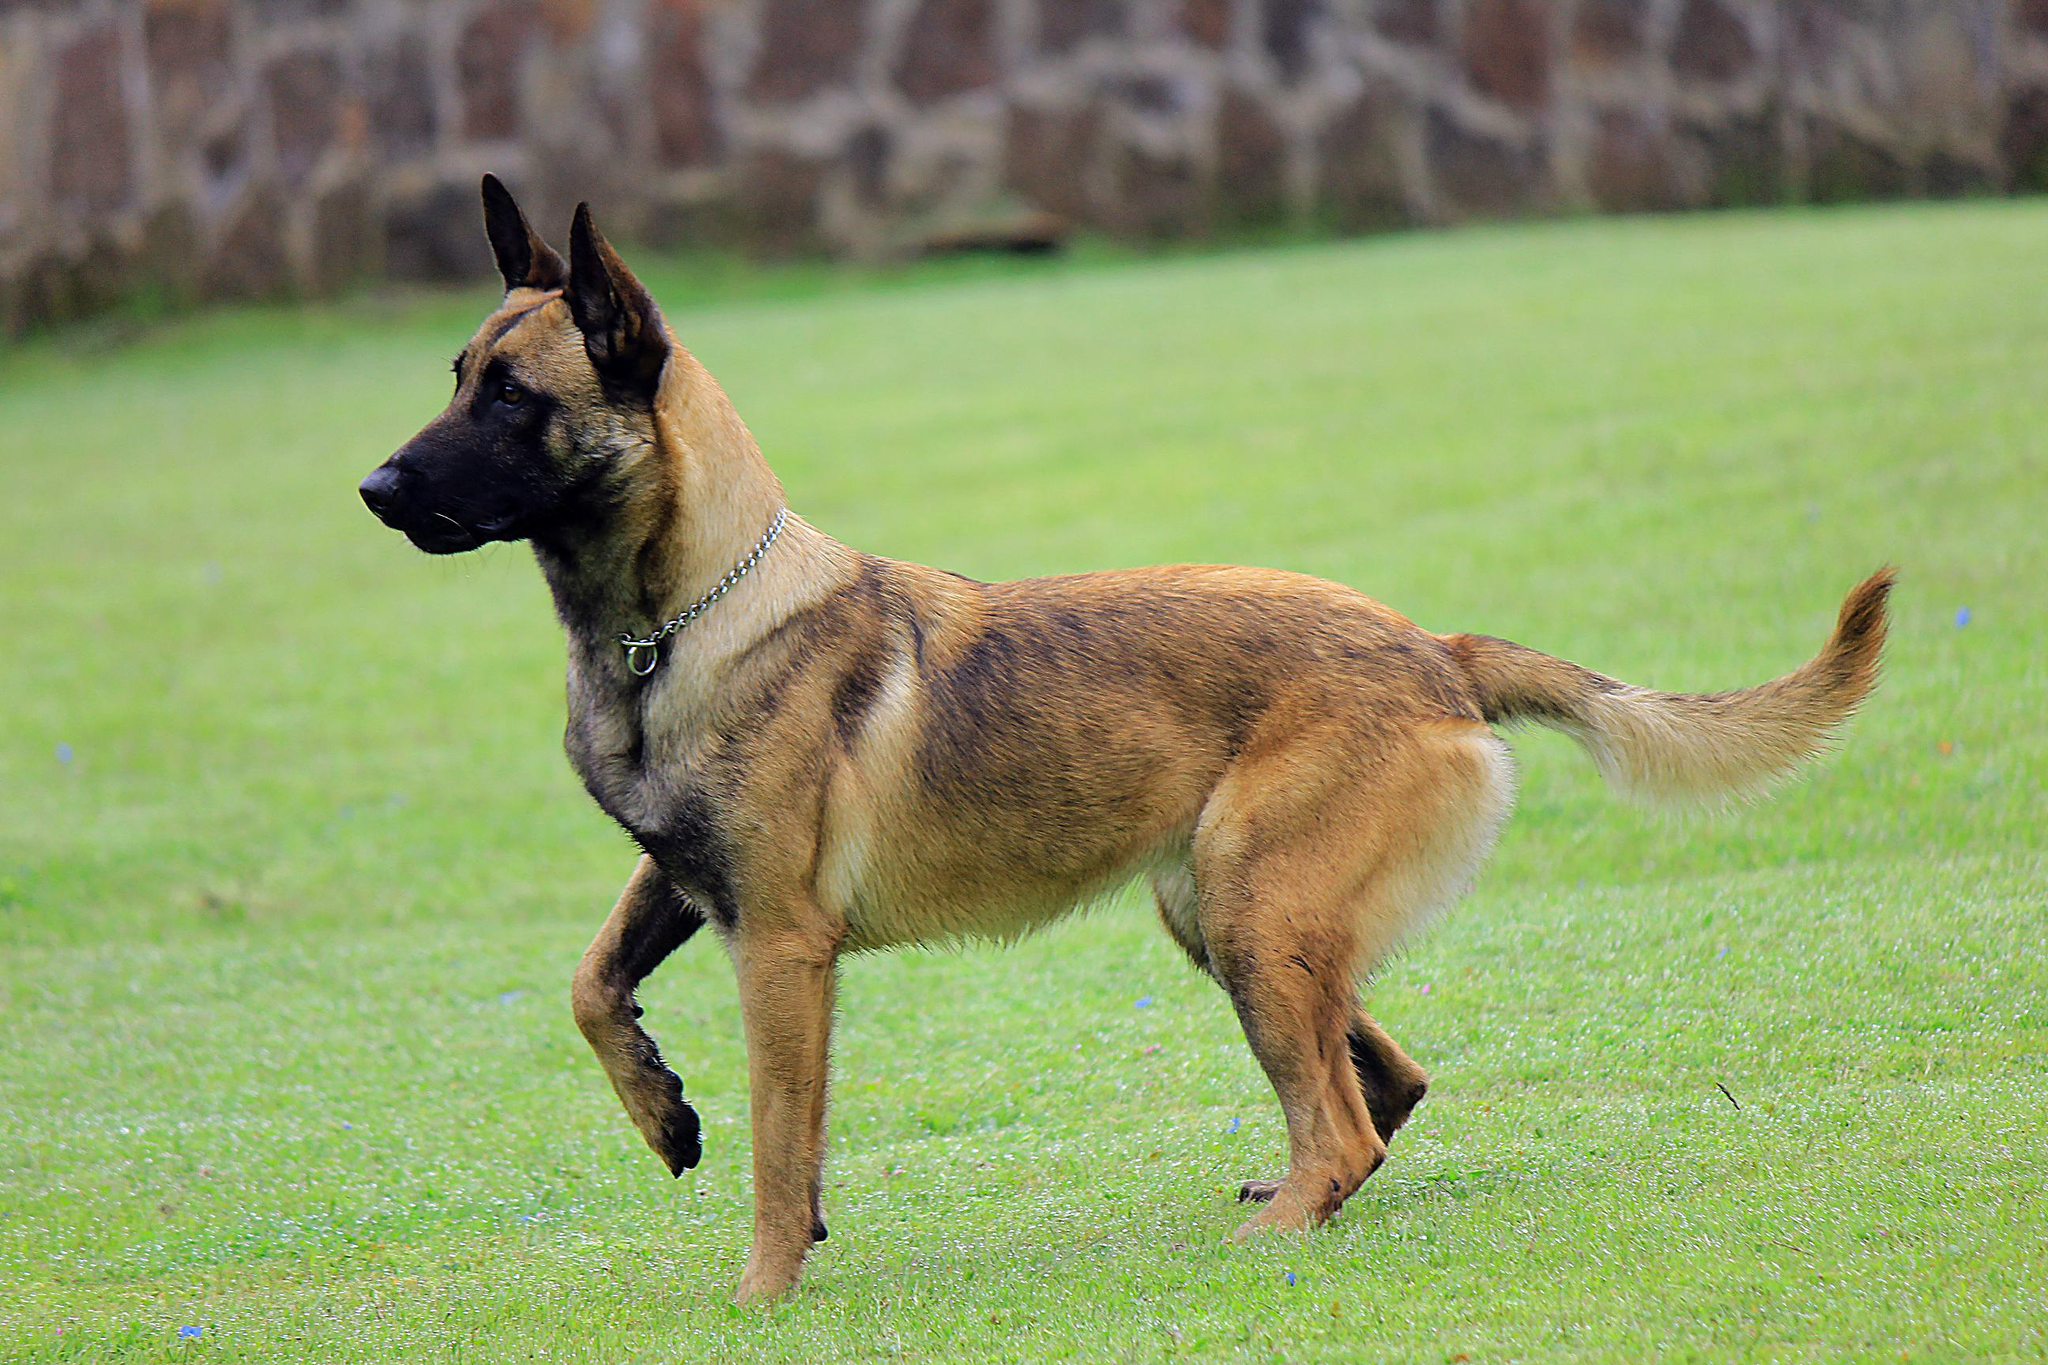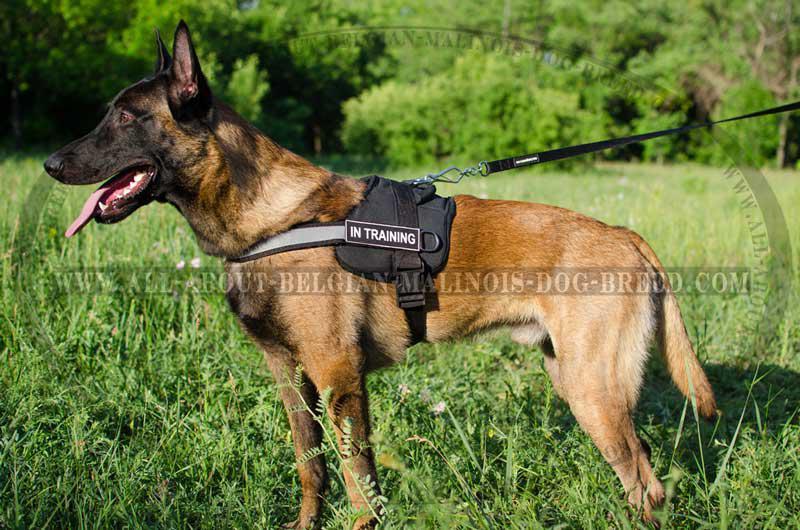The first image is the image on the left, the second image is the image on the right. For the images shown, is this caption "the right image has a dog standing on all 4's with a taught leash" true? Answer yes or no. Yes. The first image is the image on the left, the second image is the image on the right. For the images shown, is this caption "There is a total of 1 dog facing right is a grassy area." true? Answer yes or no. No. 